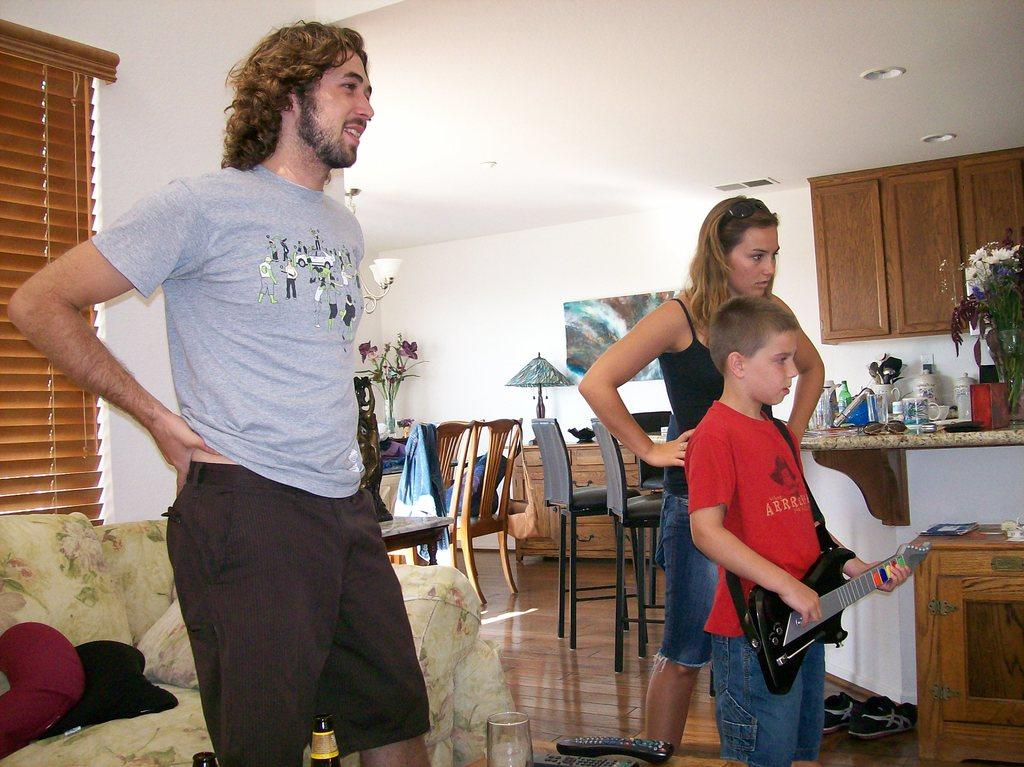How many people are in the room? There are three people in the room: a man, a woman, and a boy. What is the boy doing in the room? The boy is holding a guitar. What is on the table in the room? There are cups on the table, and there is also a flower vase on the table. What is the purpose of the table in the room? The table is likely used for placing items, such as cups and the flower vase. What is the name of the street downtown that can be seen through the window in the room? There is no window or street visible in the image, so it is not possible to determine the name of a downtown street. 